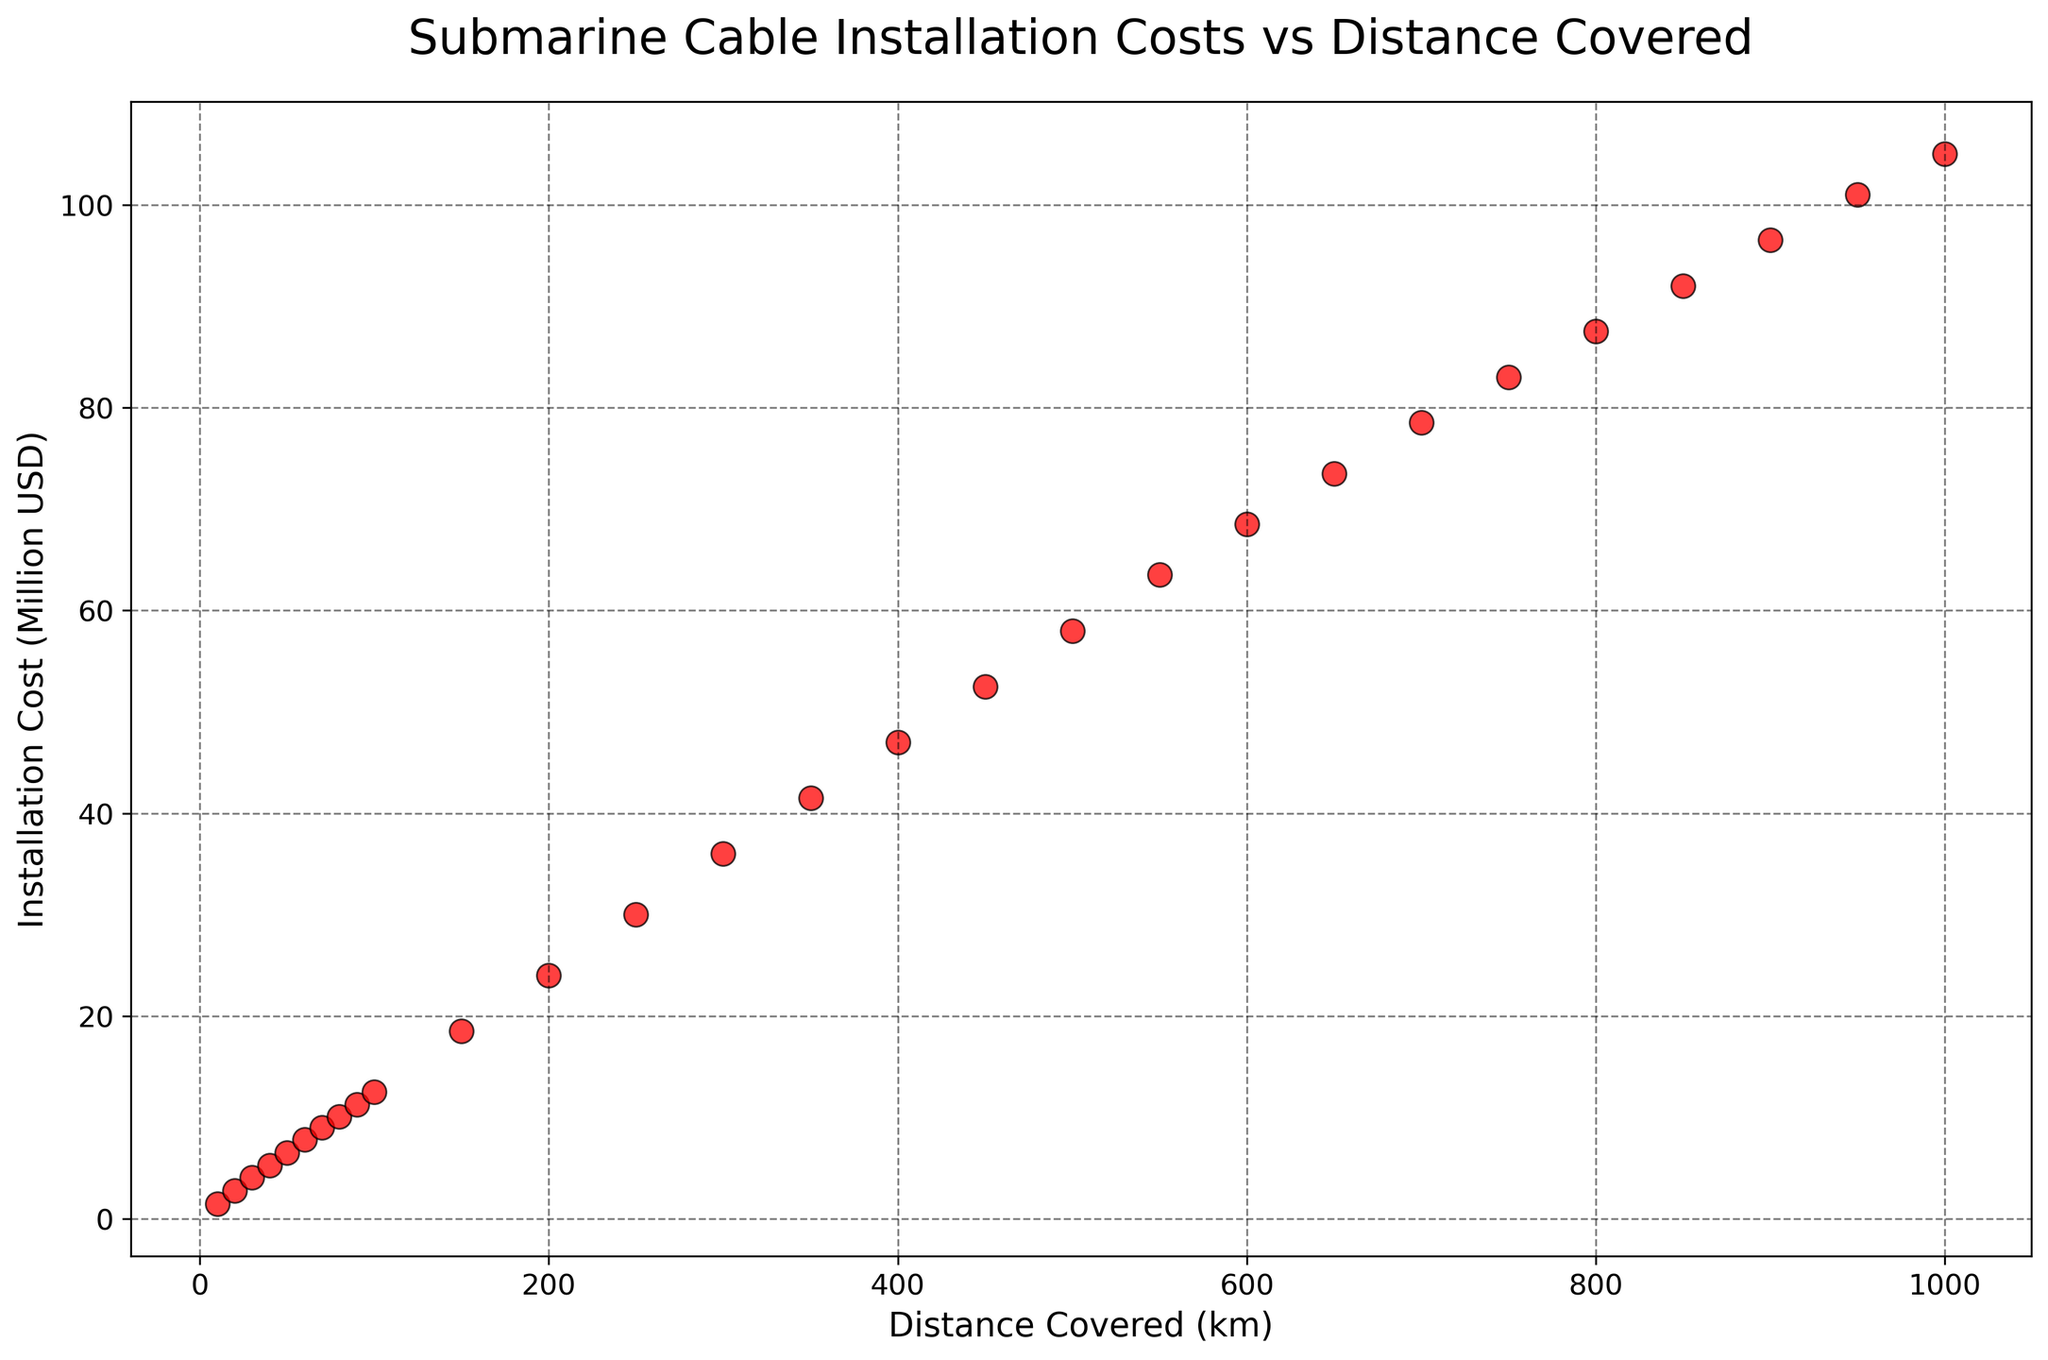How does the cost increase when the distance increases from 200 km to 400 km? The installation cost for 200 km is 24 million USD, and for 400 km is 47 million USD. The increase in cost is 47 - 24 = 23 million USD.
Answer: 23 million USD What is the average installation cost per kilometer for distances 100 km and below? The total cost for distances 10 km, 20 km, 30 km, 40 km, 50 km, 60 km, 70 km, 80 km, 90 km, and 100 km is 1.5 + 2.8 + 4.1 + 5.3 + 6.5 + 7.8 + 9.0 + 10.1 + 11.3 + 12.5 = 70.9 million USD. There are 10 data points, so the average cost per km is 70.9 / 10 = 7.09 million USD per km.
Answer: 7.09 million USD per km At what distance does the installation cost reach 50 million USD? By examining the plot, the installation cost reaches 50 million USD at approximately 450 km.
Answer: 450 km What is the rate of increase in installation cost per kilometer between 500 km and 600 km? The installation cost at 500 km is 58 million USD, and at 600 km is 68.5 million USD. The increase in cost is 68.5 - 58 = 10.5 million USD over 100 km. The rate of increase per kilometer is 10.5 / 100 = 0.105 million USD per km.
Answer: 0.105 million USD per km Which distance has the highest installation cost, and what is that cost? The highest installation cost corresponds to the maximum distance, which is 1000 km, with a cost of 105 million USD.
Answer: 1000 km, 105 million USD Compare the installation cost between 300 km and 700 km; which one is higher and by how much? At 300 km, the installation cost is 36 million USD, and at 700 km it is 78.5 million USD. The cost at 700 km is higher, and the difference is 78.5 - 36 = 42.5 million USD.
Answer: 700 km, 42.5 million USD Is the installation cost at 150 km more than twice the cost at 50 km? The cost at 150 km is 18.5 million USD, and the cost at 50 km is 6.5 million USD. Twice the cost at 50 km is 6.5 * 2 = 13 million USD. Since 18.5 million USD > 13 million USD, the cost at 150 km is indeed more than twice the cost at 50 km.
Answer: Yes What's the difference in installation cost between the shortest and the longest distances? The shortest distance (10 km) has an installation cost of 1.5 million USD, and the longest distance (1000 km) has an installation cost of 105 million USD. The difference is 105 - 1.5 = 103.5 million USD.
Answer: 103.5 million USD Do any distances show a linear relationship between distance and installation cost in the range shown? By observing the plot, it appears that the relationship between installation cost and distance is roughly linear, as the points form a near-straight line with a positive slope, indicating a steady increase in cost with distance.
Answer: Yes 